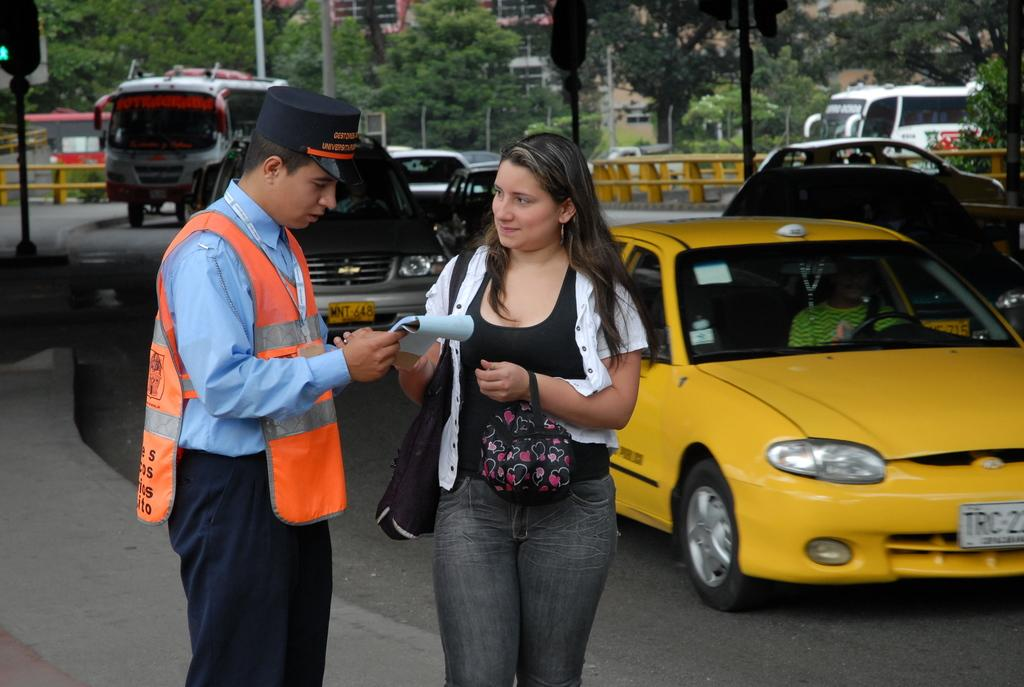<image>
Share a concise interpretation of the image provided. A yellow car with a license plate that starts out TRC drives past a woman. 